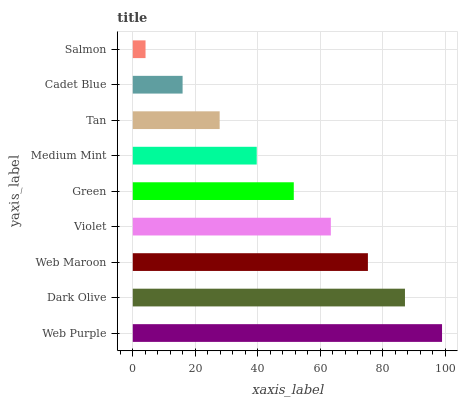Is Salmon the minimum?
Answer yes or no. Yes. Is Web Purple the maximum?
Answer yes or no. Yes. Is Dark Olive the minimum?
Answer yes or no. No. Is Dark Olive the maximum?
Answer yes or no. No. Is Web Purple greater than Dark Olive?
Answer yes or no. Yes. Is Dark Olive less than Web Purple?
Answer yes or no. Yes. Is Dark Olive greater than Web Purple?
Answer yes or no. No. Is Web Purple less than Dark Olive?
Answer yes or no. No. Is Green the high median?
Answer yes or no. Yes. Is Green the low median?
Answer yes or no. Yes. Is Dark Olive the high median?
Answer yes or no. No. Is Salmon the low median?
Answer yes or no. No. 